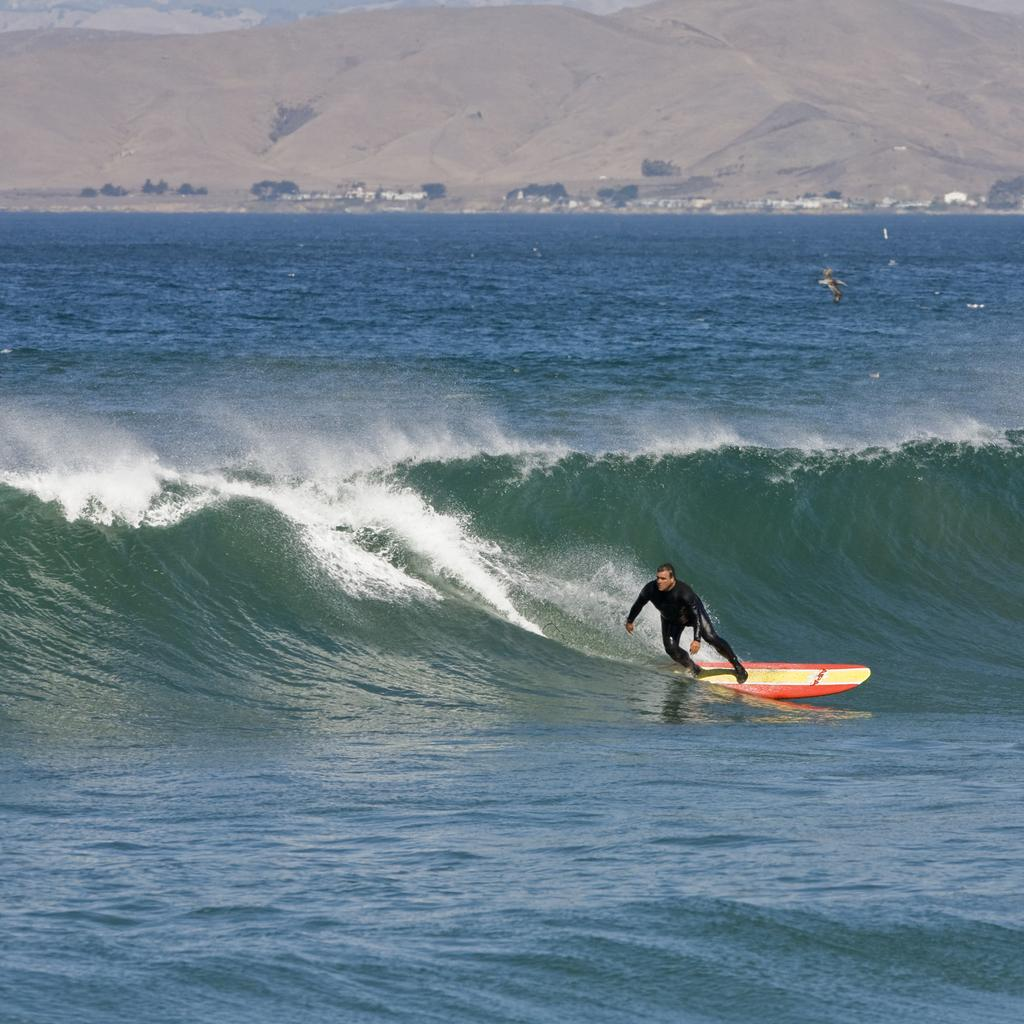Who is the main subject in the image? There is a man in the image. What is the man doing in the image? The man is surfing. On what is the man surfing? The man is surfing on waves. Where are the waves located? The waves are in a sea. What can be seen in the background of the image? There are mountains in the background of the image. Can you see any fairies flying around the man while he is surfing? No, there are no fairies present in the image. Is there a party happening on the beach in the image? There is no party visible in the image; it only shows a man surfing on waves in a sea with mountains in the background. 